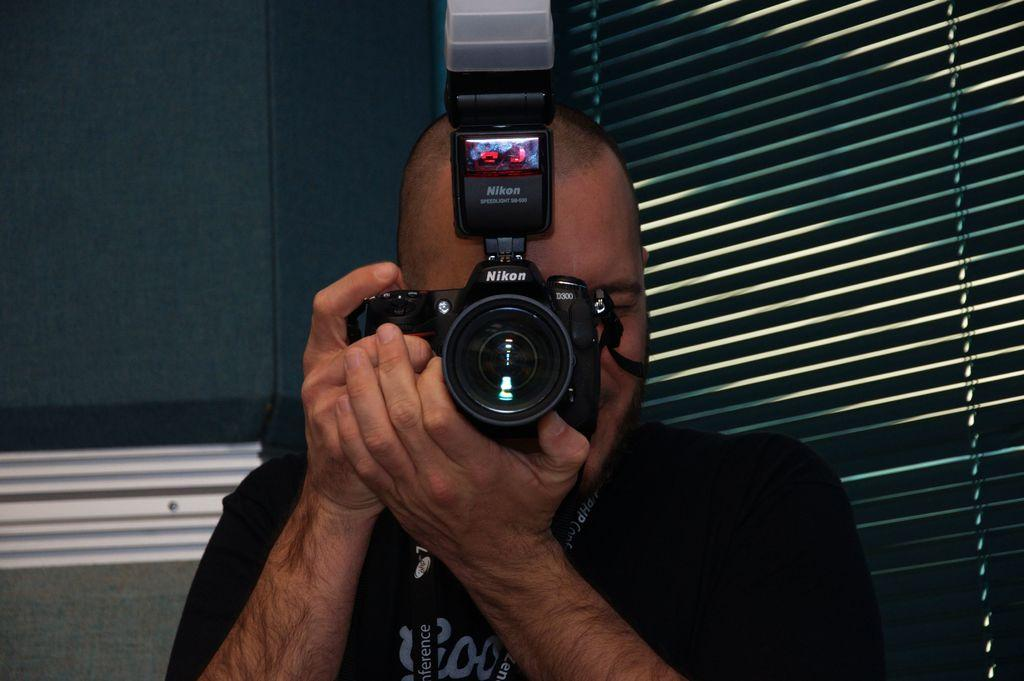What is the person in the image doing? The person is standing in the image and holding a camera. What can be seen in the background of the image? There is a wall and window shades in the background of the image. Are there any police officers on stage with the cow in the image? There is no mention of police officers, a stage, or a cow in the image; the image only features a person holding a camera and a background with a wall and window shades. 